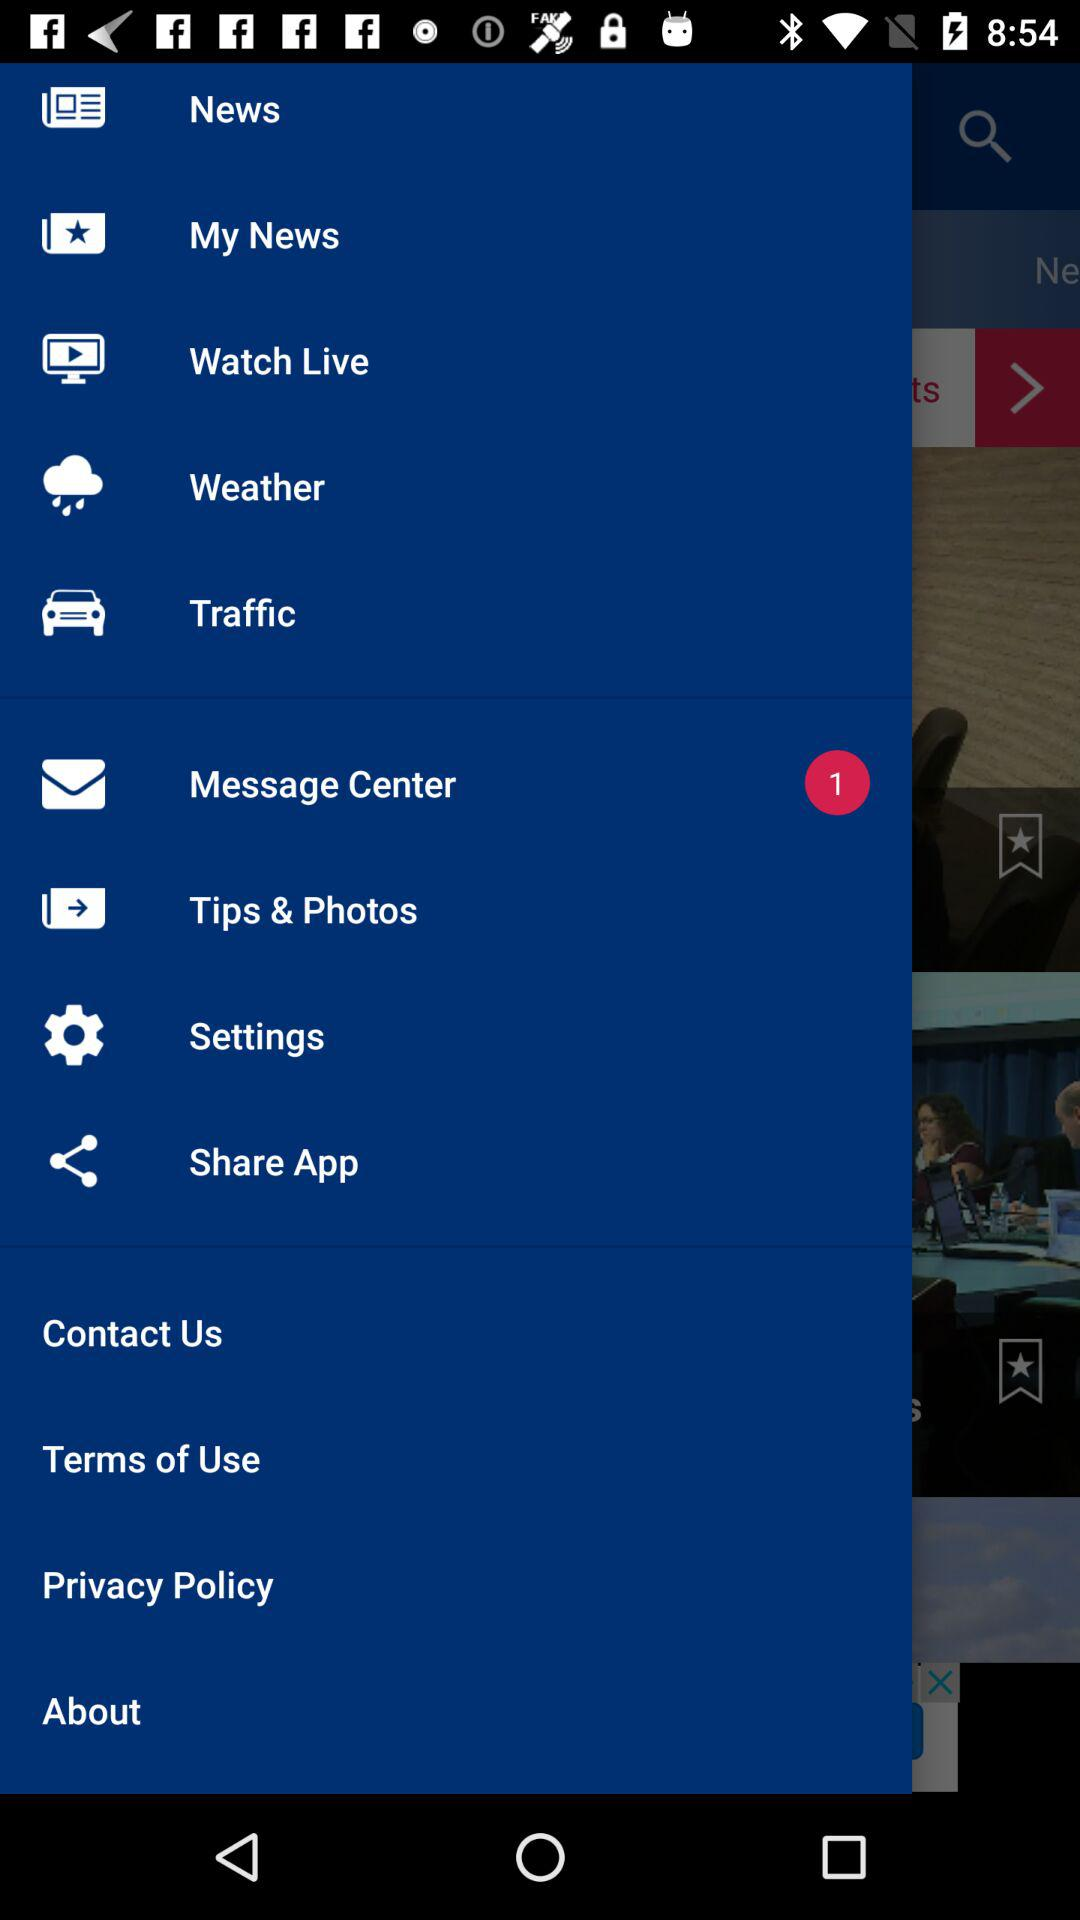How many messages are shown in "Message Center"? There is 1 message in "Message Center". 